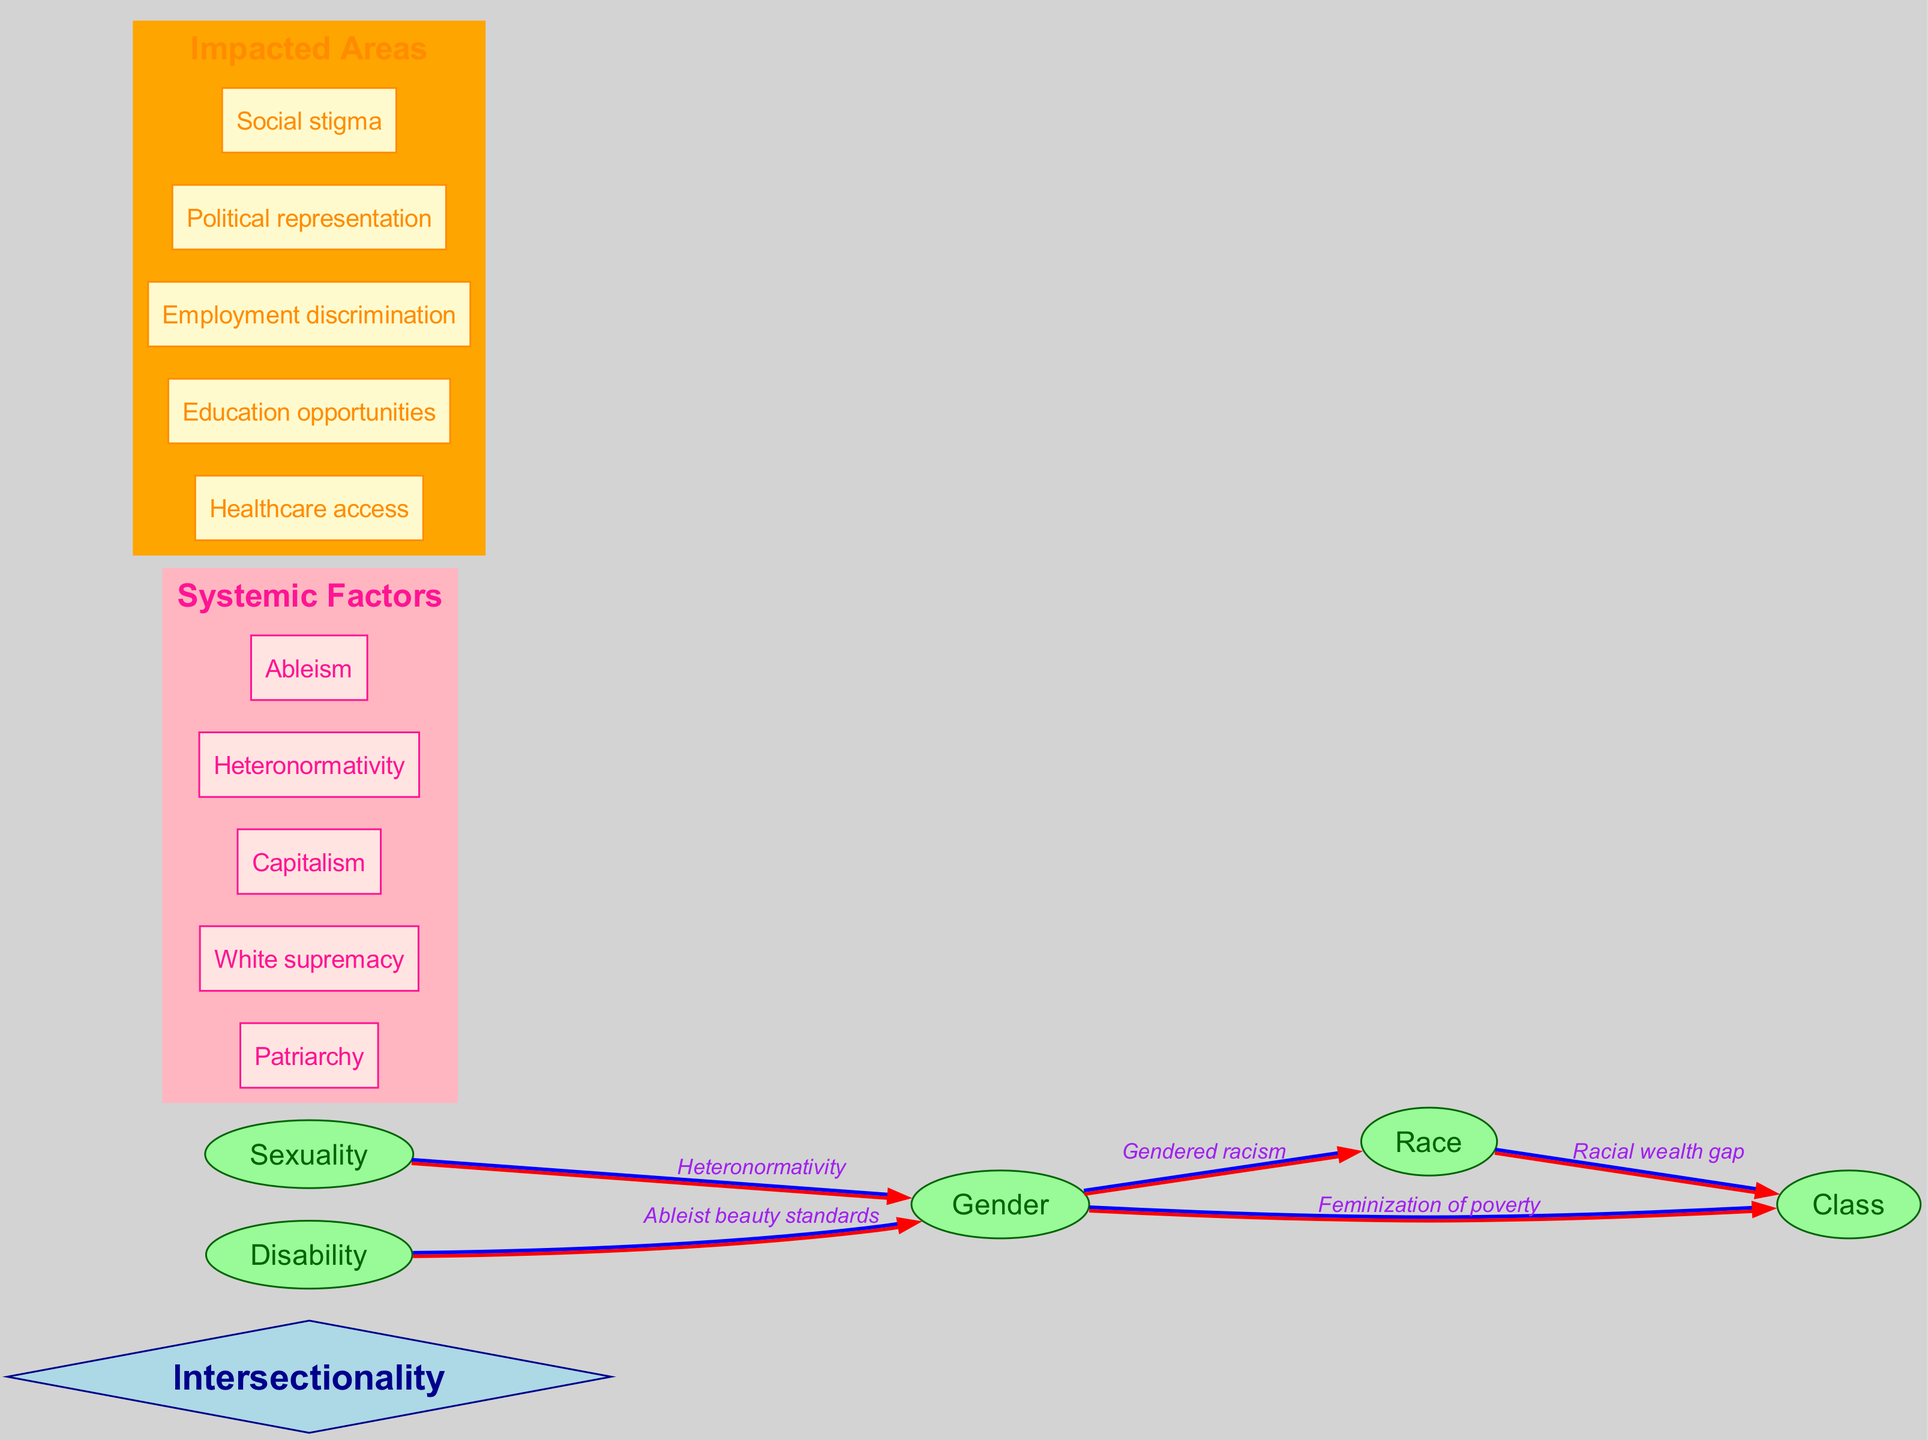What is the central concept of the diagram? The central concept is explicitly labeled as "Intersectionality" in the diagram, being at the center of the connections and categories.
Answer: Intersectionality How many main categories are displayed in the diagram? The diagram lists five main categories: Gender, Race, Class, Sexuality, and Disability. Counting these provides the answer.
Answer: 5 What type of discrimination does the connection between Gender and Race represent? The label on the connecting edge between "Gender" and "Race" specifies this relationship as "Gendered racism."
Answer: Gendered racism What systemic factor is related to both class and race? The diagram illustrates a connection between "Race" and "Class," labeled as "Racial wealth gap," showing how these systemic factors interconnect.
Answer: Racial wealth gap Which systemic factor connects to Gender through ableism? The diagram shows that "Ableism" is a systemic factor that connects to "Gender," reflected by the edge with the label "Ableist beauty standards."
Answer: Ableism What are the two main areas impacted by the intersectionality framework? The diagram indicates numerous impacted areas including healthcare access, education opportunities, employment discrimination, political representation, and social stigma; any two of these can serve as the answer.
Answer: Healthcare access, education opportunities How many unique systemic factors are listed in the diagram? There are five unique systemic factors mentioned: Patriarchy, White supremacy, Capitalism, Heteronormativity, and Ableism. This is a simple count of the factors under the "Systemic Factors" cluster.
Answer: 5 Which interconnection involves sexual orientation? The connection labeled "Heteronormativity" reflects the relationship between "Sexuality" and "Gender," indicating how sexuality intersects with gender dynamics.
Answer: Heteronormativity What is the relationship between Gender and Class? The relationship is described with the label "Feminization of poverty," which illustrates how gender dynamics impact socioeconomic status.
Answer: Feminization of poverty 